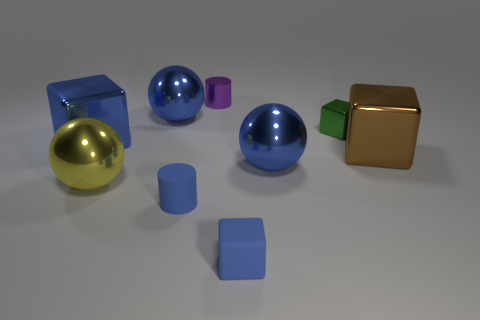Is the color of the tiny matte cube the same as the matte cylinder?
Offer a terse response. Yes. What number of shiny objects are either large purple spheres or tiny purple cylinders?
Keep it short and to the point. 1. What is the green cube made of?
Ensure brevity in your answer.  Metal. What material is the blue ball left of the small matte thing that is on the right side of the cylinder in front of the large yellow ball?
Make the answer very short. Metal. There is a green thing that is the same size as the shiny cylinder; what shape is it?
Your response must be concise. Cube. How many objects are red metal objects or small cylinders in front of the purple object?
Give a very brief answer. 1. Do the blue block to the right of the metal cylinder and the large blue ball that is to the left of the small purple object have the same material?
Your answer should be very brief. No. There is a small object that is the same color as the tiny rubber block; what is its shape?
Ensure brevity in your answer.  Cylinder. What number of cyan things are big objects or rubber blocks?
Provide a succinct answer. 0. The blue rubber cylinder has what size?
Provide a short and direct response. Small. 